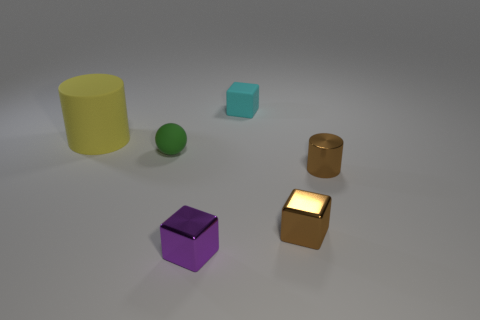What number of objects are tiny spheres or large rubber things? In the image, there appears to be one tiny sphere - the green ball, and one large rubber-looking object, which could be the yellow cylinder. Therefore, there are two objects that fit the described categories. 